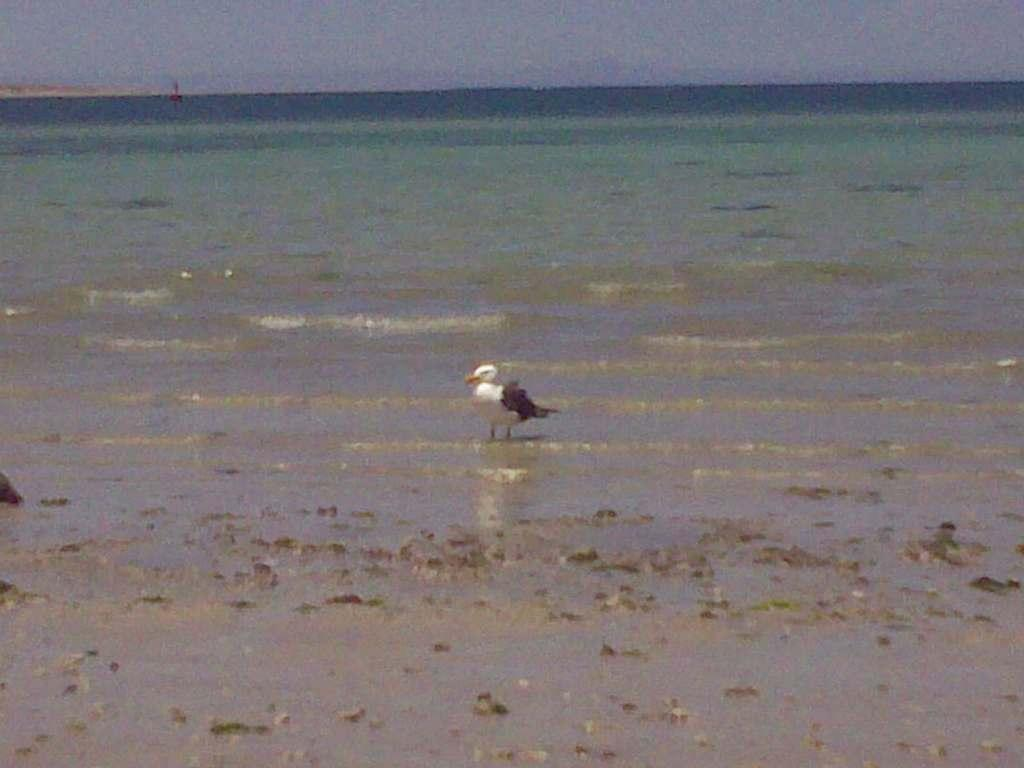What animal is present in the image? There is a duck in the image. Where is the duck located in relation to the seashore? The duck is near the seashore. What type of terrain is visible in the image? There is mud visible in the image. What natural features can be seen at the top of the image? The sea and the sky are visible at the top of the image. What statement does the duck make in the image? The duck does not make a statement in the image, as it is a non-verbal animal. 